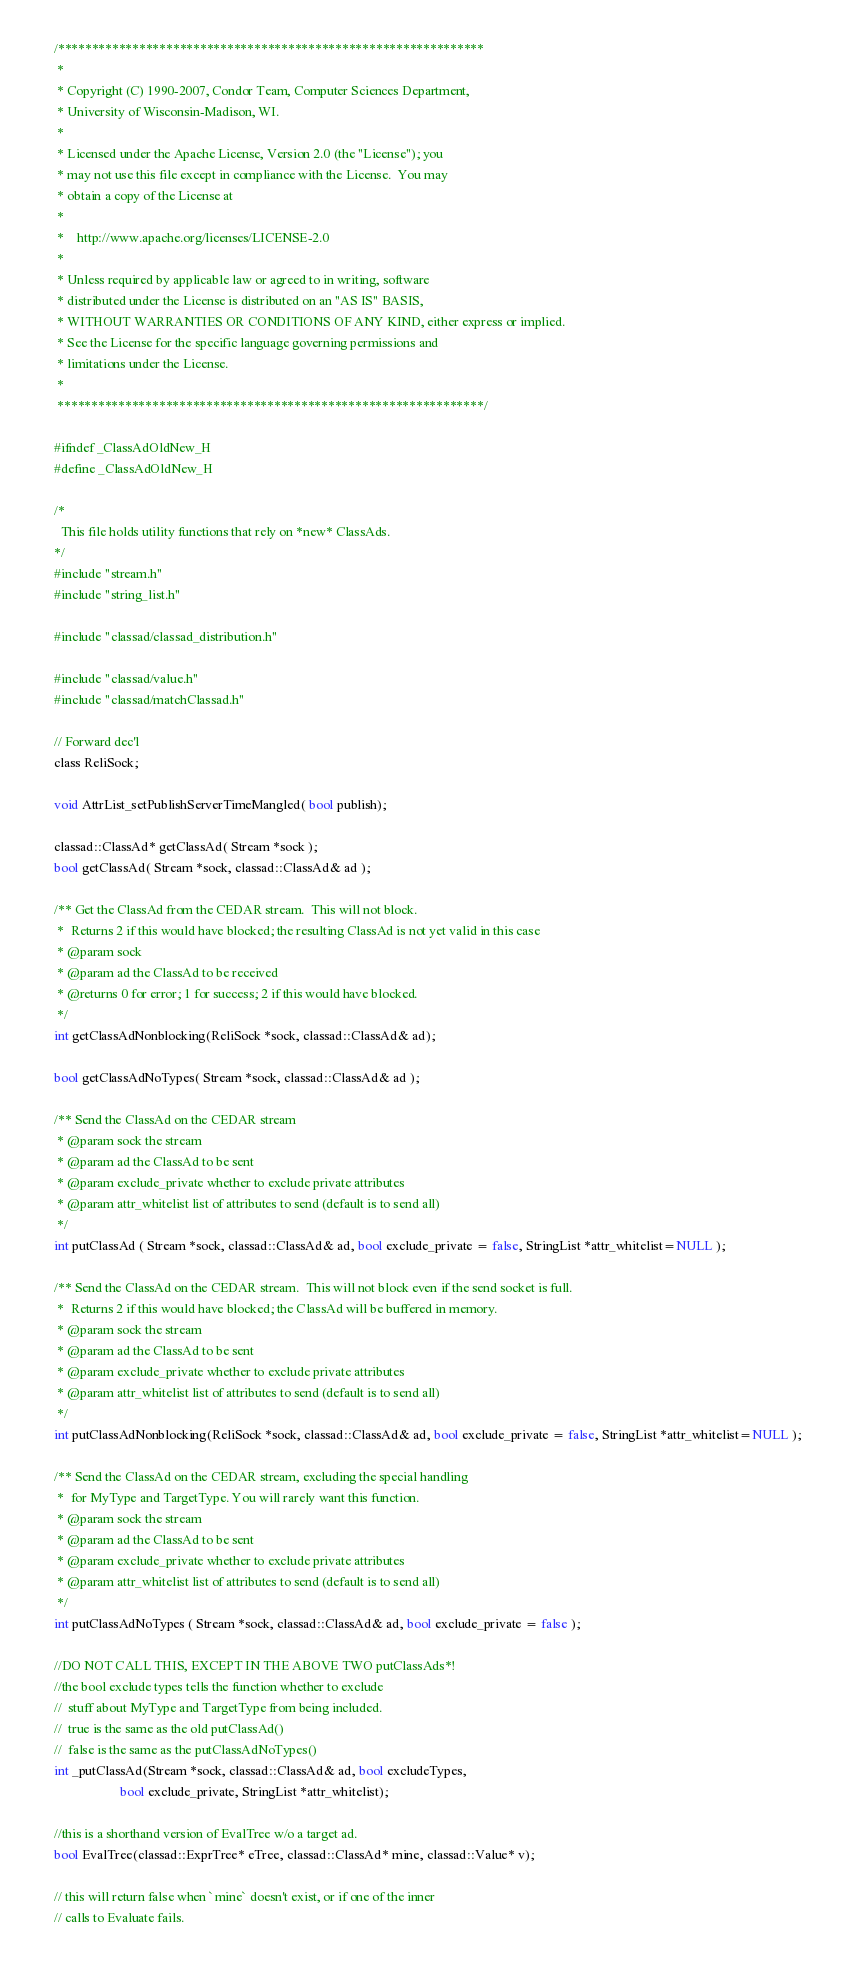<code> <loc_0><loc_0><loc_500><loc_500><_C_>/***************************************************************
 *
 * Copyright (C) 1990-2007, Condor Team, Computer Sciences Department,
 * University of Wisconsin-Madison, WI.
 * 
 * Licensed under the Apache License, Version 2.0 (the "License"); you
 * may not use this file except in compliance with the License.  You may
 * obtain a copy of the License at
 * 
 *    http://www.apache.org/licenses/LICENSE-2.0
 * 
 * Unless required by applicable law or agreed to in writing, software
 * distributed under the License is distributed on an "AS IS" BASIS,
 * WITHOUT WARRANTIES OR CONDITIONS OF ANY KIND, either express or implied.
 * See the License for the specific language governing permissions and
 * limitations under the License.
 *
 ***************************************************************/

#ifndef _ClassAdOldNew_H
#define _ClassAdOldNew_H
 
/*
  This file holds utility functions that rely on *new* ClassAds.
*/
#include "stream.h"
#include "string_list.h"

#include "classad/classad_distribution.h"

#include "classad/value.h"
#include "classad/matchClassad.h"

// Forward dec'l
class ReliSock;

void AttrList_setPublishServerTimeMangled( bool publish);

classad::ClassAd* getClassAd( Stream *sock );
bool getClassAd( Stream *sock, classad::ClassAd& ad );

/** Get the ClassAd from the CEDAR stream.  This will not block.
 *  Returns 2 if this would have blocked; the resulting ClassAd is not yet valid in this case
 * @param sock
 * @param ad the ClassAd to be received
 * @returns 0 for error; 1 for success; 2 if this would have blocked.
 */
int getClassAdNonblocking(ReliSock *sock, classad::ClassAd& ad);

bool getClassAdNoTypes( Stream *sock, classad::ClassAd& ad );

/** Send the ClassAd on the CEDAR stream
 * @param sock the stream
 * @param ad the ClassAd to be sent
 * @param exclude_private whether to exclude private attributes
 * @param attr_whitelist list of attributes to send (default is to send all)
 */
int putClassAd ( Stream *sock, classad::ClassAd& ad, bool exclude_private = false, StringList *attr_whitelist=NULL );

/** Send the ClassAd on the CEDAR stream.  This will not block even if the send socket is full.
 *  Returns 2 if this would have blocked; the ClassAd will be buffered in memory.
 * @param sock the stream
 * @param ad the ClassAd to be sent
 * @param exclude_private whether to exclude private attributes
 * @param attr_whitelist list of attributes to send (default is to send all)
 */
int putClassAdNonblocking(ReliSock *sock, classad::ClassAd& ad, bool exclude_private = false, StringList *attr_whitelist=NULL );

/** Send the ClassAd on the CEDAR stream, excluding the special handling
 *  for MyType and TargetType. You will rarely want this function.
 * @param sock the stream
 * @param ad the ClassAd to be sent
 * @param exclude_private whether to exclude private attributes
 * @param attr_whitelist list of attributes to send (default is to send all)
 */
int putClassAdNoTypes ( Stream *sock, classad::ClassAd& ad, bool exclude_private = false );

//DO NOT CALL THIS, EXCEPT IN THE ABOVE TWO putClassAds*!
//the bool exclude types tells the function whether to exclude 
//  stuff about MyType and TargetType from being included.
//  true is the same as the old putClassAd()
//  false is the same as the putClassAdNoTypes()
int _putClassAd(Stream *sock, classad::ClassAd& ad, bool excludeTypes,
					bool exclude_private, StringList *attr_whitelist);

//this is a shorthand version of EvalTree w/o a target ad.
bool EvalTree(classad::ExprTree* eTree, classad::ClassAd* mine, classad::Value* v);

// this will return false when `mine` doesn't exist, or if one of the inner
// calls to Evaluate fails.</code> 